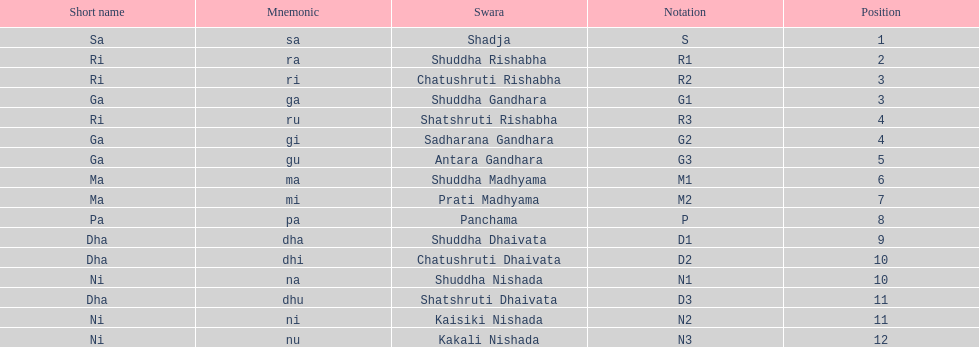Other than m1 how many notations have "1" in them? 4. 